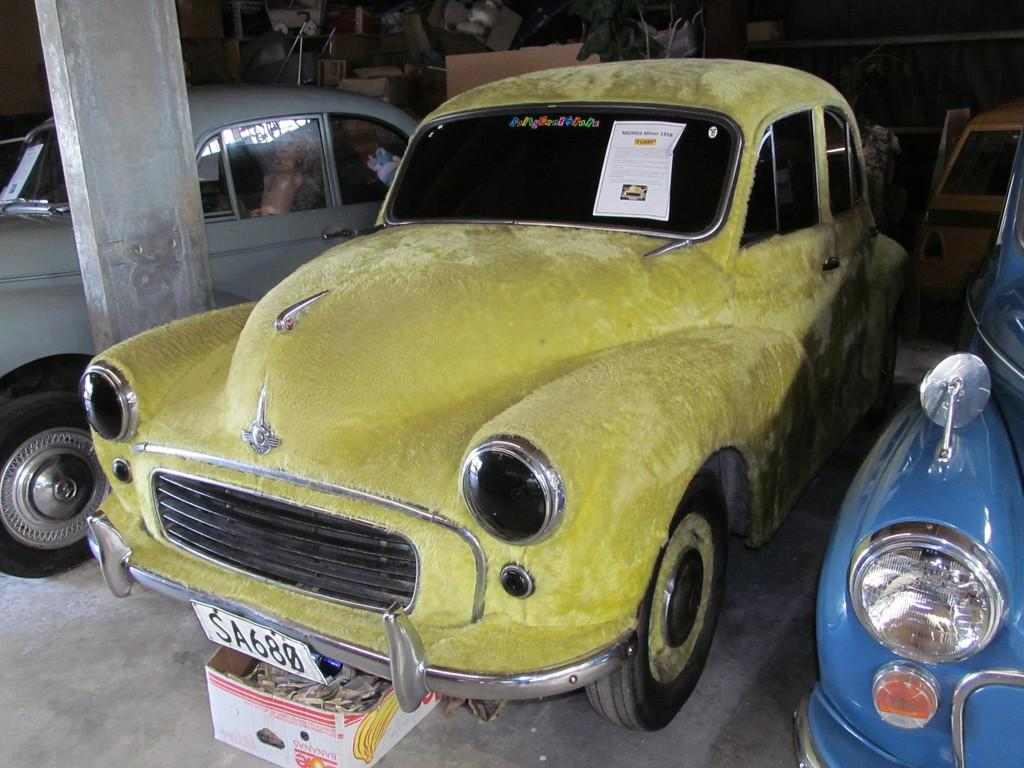What type of vehicles are present in the image? There are vintage cars in the image. What else can be seen in the image besides the vintage cars? There is a wall with accessories and a pillar on the left side of the image. How much did the clam pay for the vintage car in the image? There is no clam or payment mentioned in the image, so it is not possible to answer this question. 